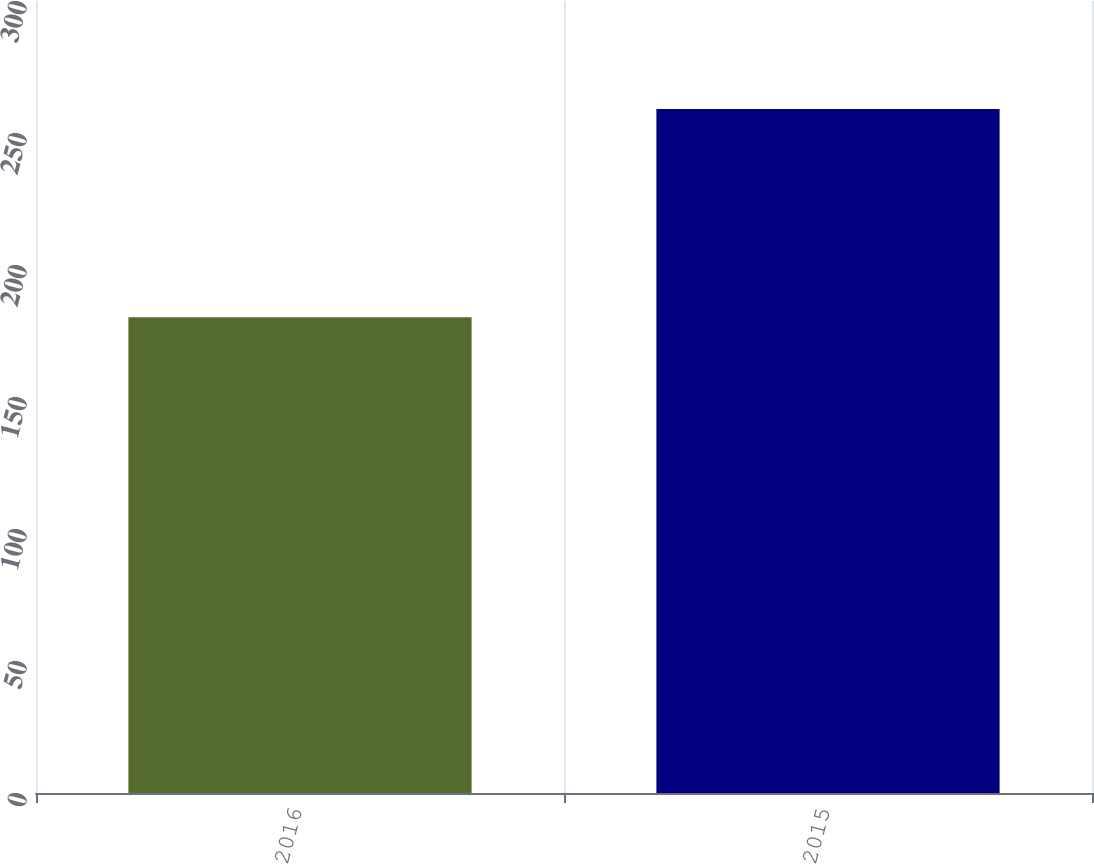Convert chart. <chart><loc_0><loc_0><loc_500><loc_500><bar_chart><fcel>2016<fcel>2015<nl><fcel>180.2<fcel>259.1<nl></chart> 